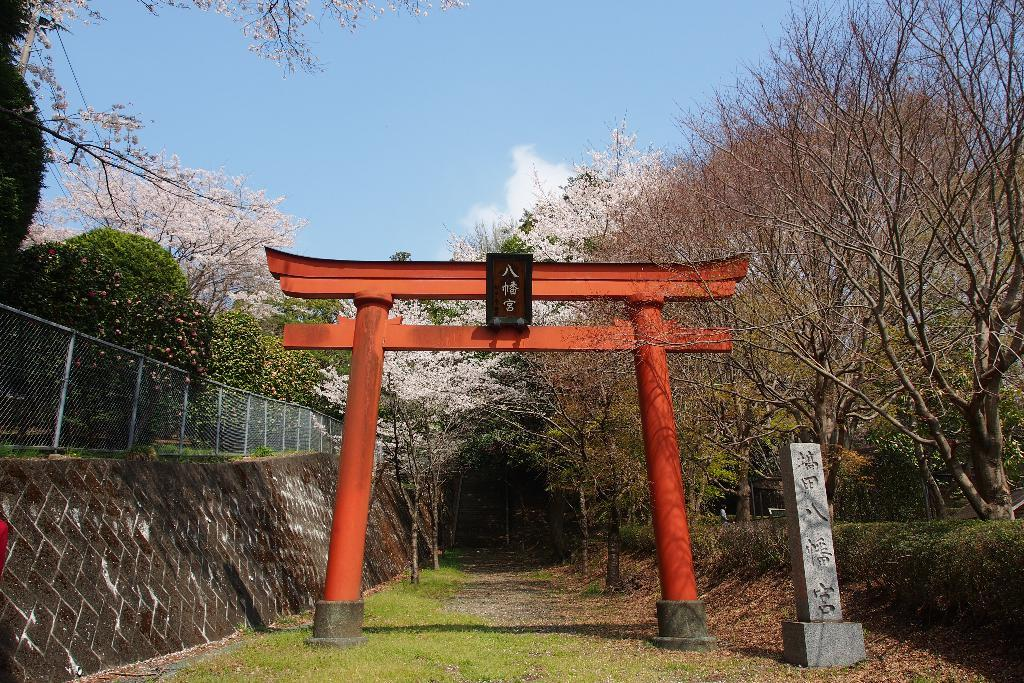What type of vegetation can be seen in the image? There are trees and flowers in the image. What is the ground covered with in the image? There is grass in the image. What type of barrier is present in the image? There is a fence in the image. What is visible at the top of the image? The sky is visible at the top of the image. Can you tell me how many parents are visible in the image? There are no parents present in the image. What type of wheel can be seen in the image? There is no wheel present in the image. What type of mine is depicted in the image? There is no mine present in the image. 